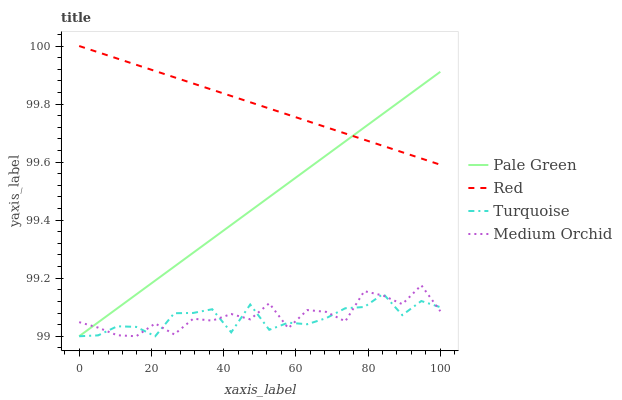Does Turquoise have the minimum area under the curve?
Answer yes or no. Yes. Does Red have the maximum area under the curve?
Answer yes or no. Yes. Does Pale Green have the minimum area under the curve?
Answer yes or no. No. Does Pale Green have the maximum area under the curve?
Answer yes or no. No. Is Pale Green the smoothest?
Answer yes or no. Yes. Is Medium Orchid the roughest?
Answer yes or no. Yes. Is Turquoise the smoothest?
Answer yes or no. No. Is Turquoise the roughest?
Answer yes or no. No. Does Medium Orchid have the lowest value?
Answer yes or no. Yes. Does Red have the lowest value?
Answer yes or no. No. Does Red have the highest value?
Answer yes or no. Yes. Does Pale Green have the highest value?
Answer yes or no. No. Is Medium Orchid less than Red?
Answer yes or no. Yes. Is Red greater than Medium Orchid?
Answer yes or no. Yes. Does Pale Green intersect Turquoise?
Answer yes or no. Yes. Is Pale Green less than Turquoise?
Answer yes or no. No. Is Pale Green greater than Turquoise?
Answer yes or no. No. Does Medium Orchid intersect Red?
Answer yes or no. No. 